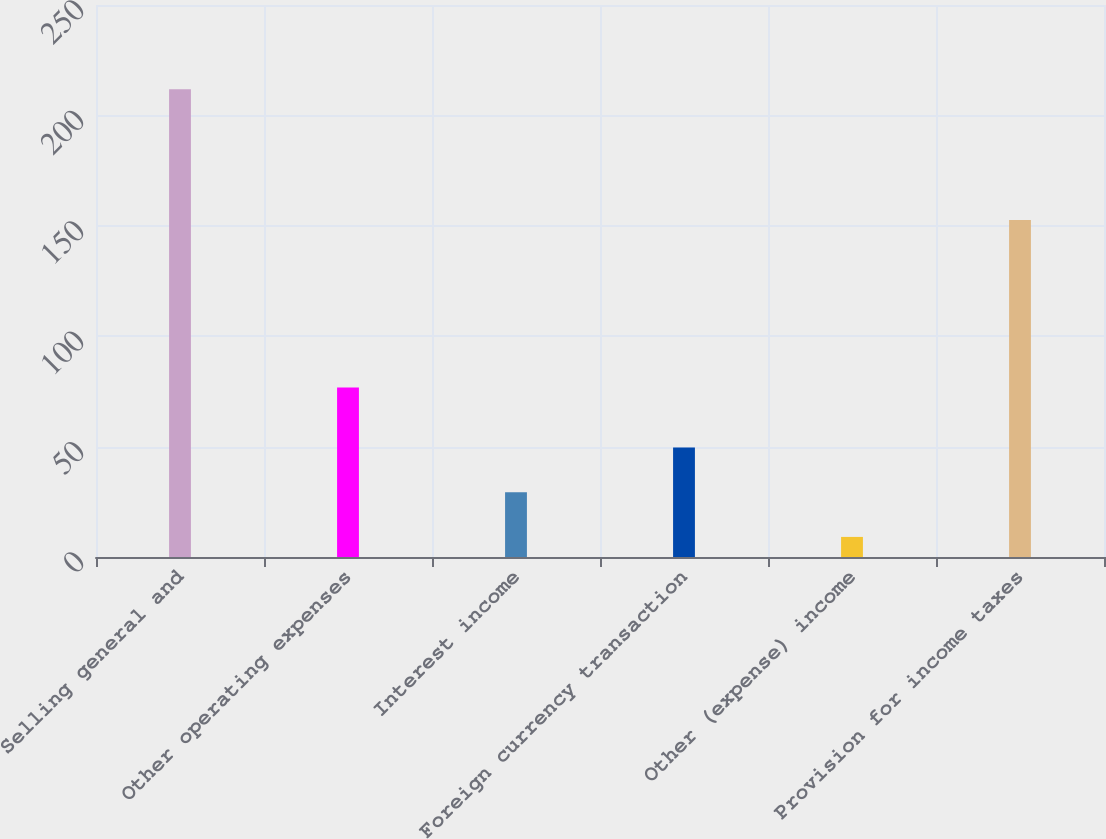<chart> <loc_0><loc_0><loc_500><loc_500><bar_chart><fcel>Selling general and<fcel>Other operating expenses<fcel>Interest income<fcel>Foreign currency transaction<fcel>Other (expense) income<fcel>Provision for income taxes<nl><fcel>211.8<fcel>76.8<fcel>29.37<fcel>49.64<fcel>9.1<fcel>152.6<nl></chart> 